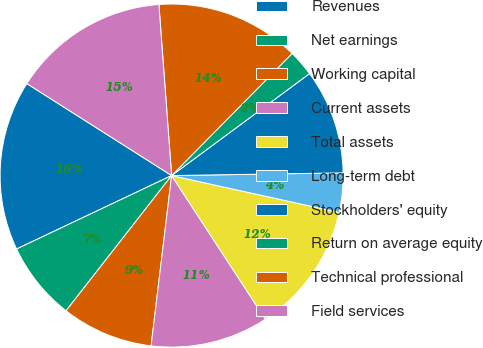Convert chart. <chart><loc_0><loc_0><loc_500><loc_500><pie_chart><fcel>Revenues<fcel>Net earnings<fcel>Working capital<fcel>Current assets<fcel>Total assets<fcel>Long-term debt<fcel>Stockholders' equity<fcel>Return on average equity<fcel>Technical professional<fcel>Field services<nl><fcel>16.05%<fcel>7.41%<fcel>8.64%<fcel>11.11%<fcel>12.35%<fcel>3.7%<fcel>9.88%<fcel>2.47%<fcel>13.58%<fcel>14.81%<nl></chart> 